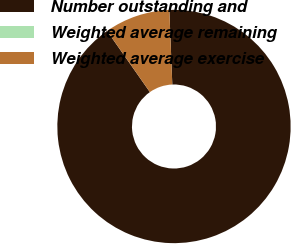Convert chart to OTSL. <chart><loc_0><loc_0><loc_500><loc_500><pie_chart><fcel>Number outstanding and<fcel>Weighted average remaining<fcel>Weighted average exercise<nl><fcel>90.91%<fcel>0.0%<fcel>9.09%<nl></chart> 